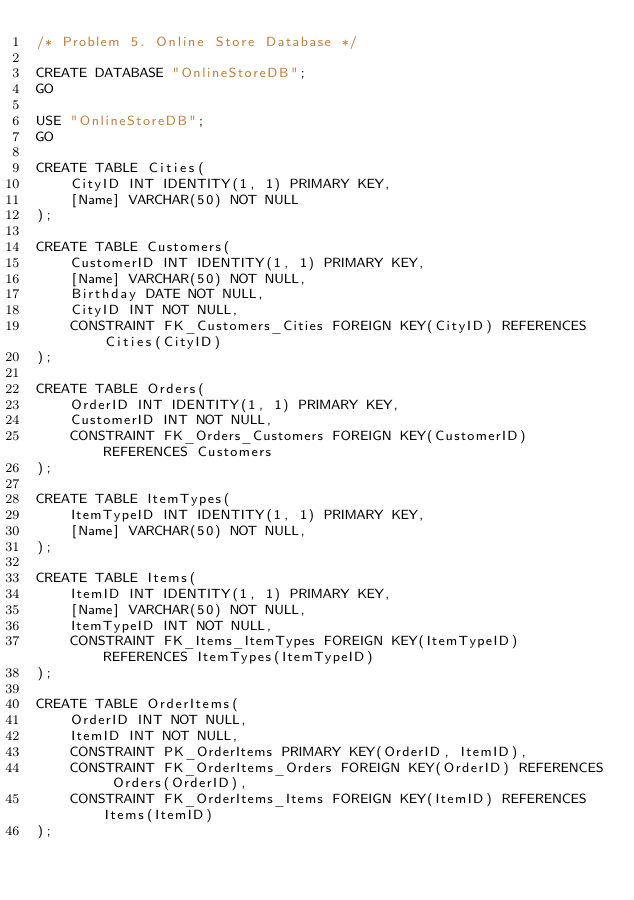<code> <loc_0><loc_0><loc_500><loc_500><_SQL_>/* Problem 5. Online Store Database */

CREATE DATABASE "OnlineStoreDB";
GO

USE "OnlineStoreDB";
GO

CREATE TABLE Cities(
	CityID INT IDENTITY(1, 1) PRIMARY KEY,
	[Name] VARCHAR(50) NOT NULL
);

CREATE TABLE Customers(
	CustomerID INT IDENTITY(1, 1) PRIMARY KEY,
	[Name] VARCHAR(50) NOT NULL,
	Birthday DATE NOT NULL,
	CityID INT NOT NULL,
	CONSTRAINT FK_Customers_Cities FOREIGN KEY(CityID) REFERENCES Cities(CityID)
);

CREATE TABLE Orders(
	OrderID INT IDENTITY(1, 1) PRIMARY KEY,
	CustomerID INT NOT NULL,
	CONSTRAINT FK_Orders_Customers FOREIGN KEY(CustomerID) REFERENCES Customers
);

CREATE TABLE ItemTypes(
	ItemTypeID INT IDENTITY(1, 1) PRIMARY KEY,
	[Name] VARCHAR(50) NOT NULL,
);

CREATE TABLE Items(
	ItemID INT IDENTITY(1, 1) PRIMARY KEY,
	[Name] VARCHAR(50) NOT NULL,
	ItemTypeID INT NOT NULL,
	CONSTRAINT FK_Items_ItemTypes FOREIGN KEY(ItemTypeID) REFERENCES ItemTypes(ItemTypeID)
);

CREATE TABLE OrderItems(
	OrderID INT NOT NULL,
	ItemID INT NOT NULL,
	CONSTRAINT PK_OrderItems PRIMARY KEY(OrderID, ItemID),
	CONSTRAINT FK_OrderItems_Orders FOREIGN KEY(OrderID) REFERENCES Orders(OrderID),
	CONSTRAINT FK_OrderItems_Items FOREIGN KEY(ItemID) REFERENCES Items(ItemID)
);</code> 